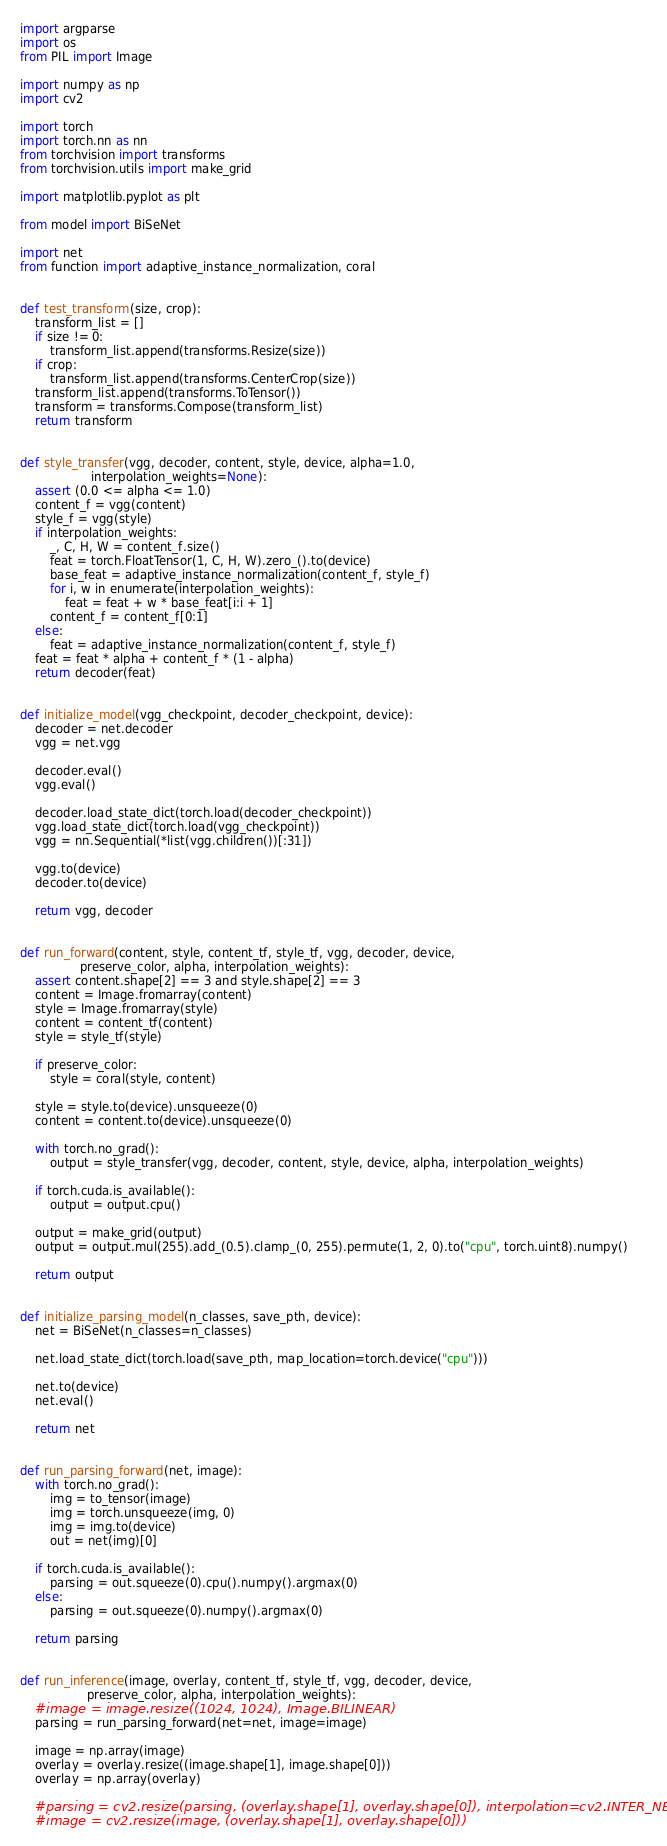<code> <loc_0><loc_0><loc_500><loc_500><_Python_>import argparse
import os
from PIL import Image

import numpy as np
import cv2

import torch
import torch.nn as nn
from torchvision import transforms
from torchvision.utils import make_grid

import matplotlib.pyplot as plt

from model import BiSeNet

import net
from function import adaptive_instance_normalization, coral


def test_transform(size, crop):
    transform_list = []
    if size != 0:
        transform_list.append(transforms.Resize(size))
    if crop:
        transform_list.append(transforms.CenterCrop(size))
    transform_list.append(transforms.ToTensor())
    transform = transforms.Compose(transform_list)
    return transform


def style_transfer(vgg, decoder, content, style, device, alpha=1.0,
                   interpolation_weights=None):
    assert (0.0 <= alpha <= 1.0)
    content_f = vgg(content)
    style_f = vgg(style)
    if interpolation_weights:
        _, C, H, W = content_f.size()
        feat = torch.FloatTensor(1, C, H, W).zero_().to(device)
        base_feat = adaptive_instance_normalization(content_f, style_f)
        for i, w in enumerate(interpolation_weights):
            feat = feat + w * base_feat[i:i + 1]
        content_f = content_f[0:1]
    else:
        feat = adaptive_instance_normalization(content_f, style_f)
    feat = feat * alpha + content_f * (1 - alpha)
    return decoder(feat)


def initialize_model(vgg_checkpoint, decoder_checkpoint, device):
    decoder = net.decoder
    vgg = net.vgg

    decoder.eval()
    vgg.eval()

    decoder.load_state_dict(torch.load(decoder_checkpoint))
    vgg.load_state_dict(torch.load(vgg_checkpoint))
    vgg = nn.Sequential(*list(vgg.children())[:31])

    vgg.to(device)
    decoder.to(device)

    return vgg, decoder


def run_forward(content, style, content_tf, style_tf, vgg, decoder, device,
                preserve_color, alpha, interpolation_weights):
    assert content.shape[2] == 3 and style.shape[2] == 3
    content = Image.fromarray(content)
    style = Image.fromarray(style)
    content = content_tf(content)
    style = style_tf(style)

    if preserve_color:
        style = coral(style, content)

    style = style.to(device).unsqueeze(0)
    content = content.to(device).unsqueeze(0)

    with torch.no_grad():
        output = style_transfer(vgg, decoder, content, style, device, alpha, interpolation_weights)

    if torch.cuda.is_available():
        output = output.cpu()

    output = make_grid(output)
    output = output.mul(255).add_(0.5).clamp_(0, 255).permute(1, 2, 0).to("cpu", torch.uint8).numpy()

    return output


def initialize_parsing_model(n_classes, save_pth, device):
    net = BiSeNet(n_classes=n_classes)

    net.load_state_dict(torch.load(save_pth, map_location=torch.device("cpu")))

    net.to(device)
    net.eval()

    return net


def run_parsing_forward(net, image):
    with torch.no_grad():
        img = to_tensor(image)
        img = torch.unsqueeze(img, 0)
        img = img.to(device)
        out = net(img)[0]

    if torch.cuda.is_available():
        parsing = out.squeeze(0).cpu().numpy().argmax(0)
    else:
        parsing = out.squeeze(0).numpy().argmax(0)

    return parsing


def run_inference(image, overlay, content_tf, style_tf, vgg, decoder, device,
                  preserve_color, alpha, interpolation_weights):
    #image = image.resize((1024, 1024), Image.BILINEAR)
    parsing = run_parsing_forward(net=net, image=image)

    image = np.array(image)
    overlay = overlay.resize((image.shape[1], image.shape[0]))
    overlay = np.array(overlay)

    #parsing = cv2.resize(parsing, (overlay.shape[1], overlay.shape[0]), interpolation=cv2.INTER_NEAREST)
    #image = cv2.resize(image, (overlay.shape[1], overlay.shape[0]))
</code> 